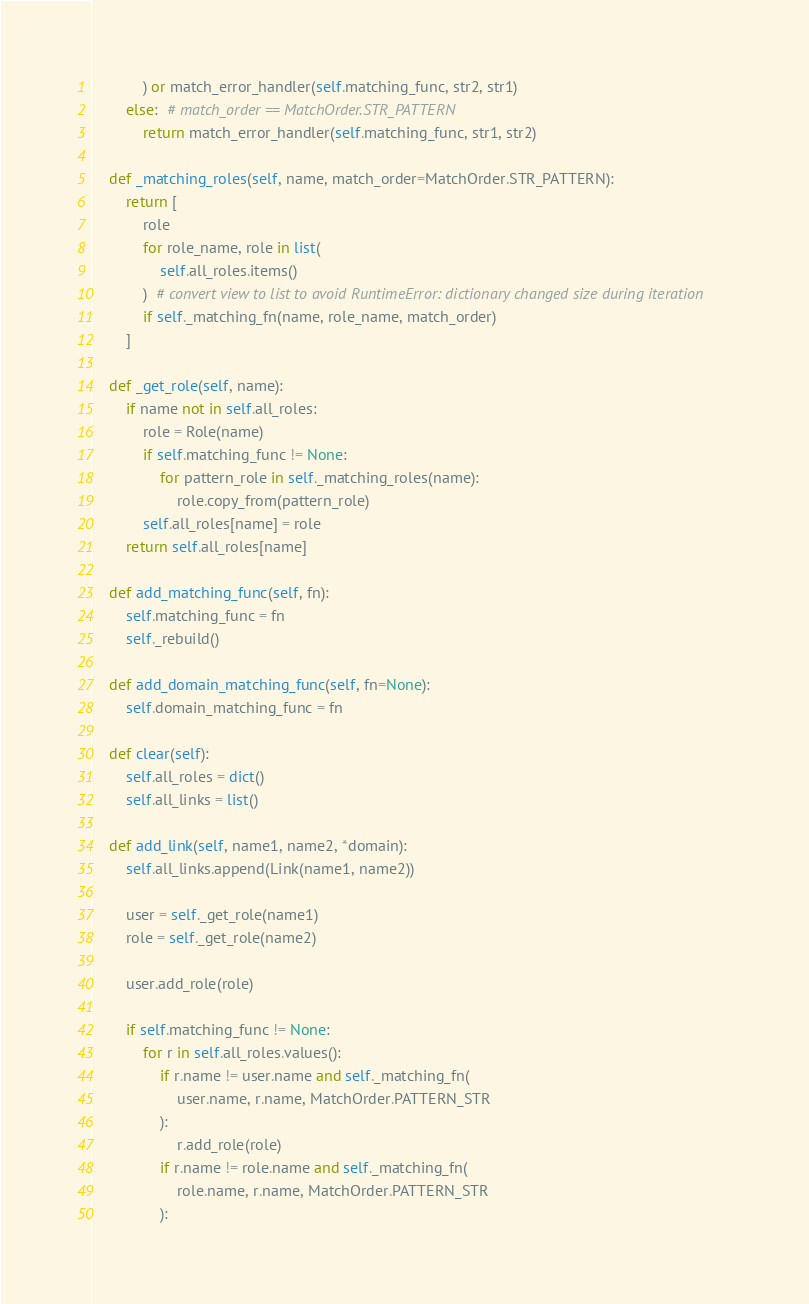<code> <loc_0><loc_0><loc_500><loc_500><_Python_>            ) or match_error_handler(self.matching_func, str2, str1)
        else:  # match_order == MatchOrder.STR_PATTERN
            return match_error_handler(self.matching_func, str1, str2)

    def _matching_roles(self, name, match_order=MatchOrder.STR_PATTERN):
        return [
            role
            for role_name, role in list(
                self.all_roles.items()
            )  # convert view to list to avoid RuntimeError: dictionary changed size during iteration
            if self._matching_fn(name, role_name, match_order)
        ]

    def _get_role(self, name):
        if name not in self.all_roles:
            role = Role(name)
            if self.matching_func != None:
                for pattern_role in self._matching_roles(name):
                    role.copy_from(pattern_role)
            self.all_roles[name] = role
        return self.all_roles[name]

    def add_matching_func(self, fn):
        self.matching_func = fn
        self._rebuild()

    def add_domain_matching_func(self, fn=None):
        self.domain_matching_func = fn

    def clear(self):
        self.all_roles = dict()
        self.all_links = list()

    def add_link(self, name1, name2, *domain):
        self.all_links.append(Link(name1, name2))

        user = self._get_role(name1)
        role = self._get_role(name2)

        user.add_role(role)

        if self.matching_func != None:
            for r in self.all_roles.values():
                if r.name != user.name and self._matching_fn(
                    user.name, r.name, MatchOrder.PATTERN_STR
                ):
                    r.add_role(role)
                if r.name != role.name and self._matching_fn(
                    role.name, r.name, MatchOrder.PATTERN_STR
                ):</code> 